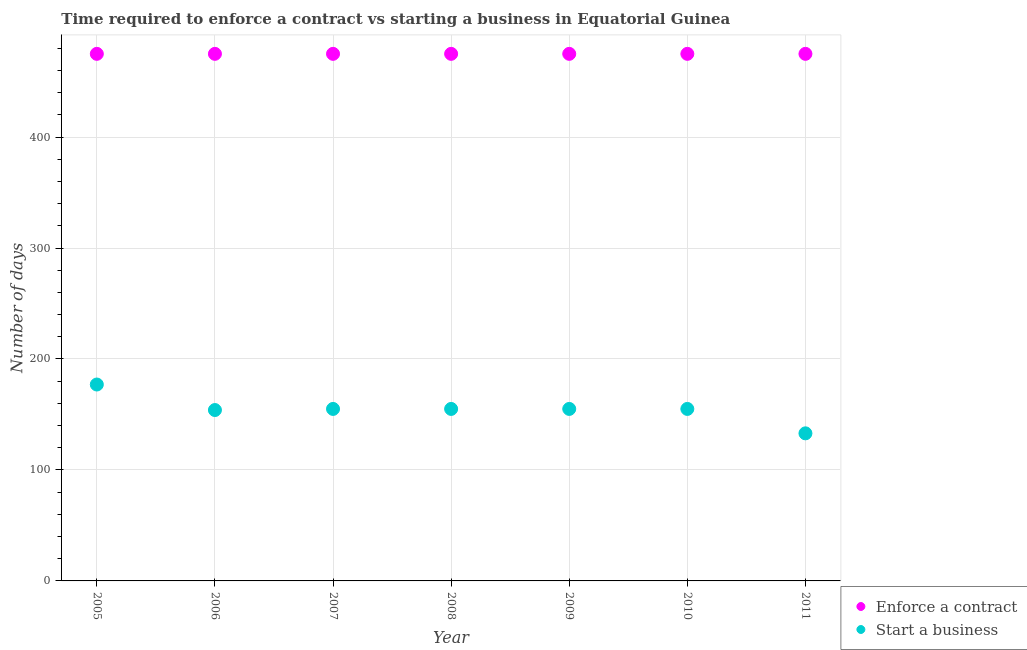What is the number of days to start a business in 2010?
Ensure brevity in your answer.  155. Across all years, what is the maximum number of days to start a business?
Keep it short and to the point. 177. Across all years, what is the minimum number of days to enforece a contract?
Make the answer very short. 475. In which year was the number of days to start a business maximum?
Ensure brevity in your answer.  2005. In which year was the number of days to enforece a contract minimum?
Provide a short and direct response. 2005. What is the total number of days to enforece a contract in the graph?
Provide a succinct answer. 3325. What is the difference between the number of days to start a business in 2005 and that in 2006?
Provide a succinct answer. 23. What is the difference between the number of days to start a business in 2008 and the number of days to enforece a contract in 2009?
Your answer should be compact. -320. What is the average number of days to enforece a contract per year?
Offer a very short reply. 475. In the year 2008, what is the difference between the number of days to start a business and number of days to enforece a contract?
Give a very brief answer. -320. In how many years, is the number of days to enforece a contract greater than 140 days?
Ensure brevity in your answer.  7. What is the ratio of the number of days to start a business in 2008 to that in 2011?
Keep it short and to the point. 1.17. Is the difference between the number of days to enforece a contract in 2007 and 2009 greater than the difference between the number of days to start a business in 2007 and 2009?
Provide a short and direct response. No. What is the difference between the highest and the second highest number of days to enforece a contract?
Your answer should be compact. 0. In how many years, is the number of days to start a business greater than the average number of days to start a business taken over all years?
Ensure brevity in your answer.  5. Is the sum of the number of days to enforece a contract in 2007 and 2008 greater than the maximum number of days to start a business across all years?
Provide a succinct answer. Yes. How many dotlines are there?
Ensure brevity in your answer.  2. How many years are there in the graph?
Keep it short and to the point. 7. What is the difference between two consecutive major ticks on the Y-axis?
Your answer should be very brief. 100. Are the values on the major ticks of Y-axis written in scientific E-notation?
Your answer should be compact. No. Does the graph contain any zero values?
Your response must be concise. No. Where does the legend appear in the graph?
Offer a very short reply. Bottom right. How many legend labels are there?
Offer a terse response. 2. What is the title of the graph?
Your answer should be compact. Time required to enforce a contract vs starting a business in Equatorial Guinea. What is the label or title of the Y-axis?
Your answer should be compact. Number of days. What is the Number of days of Enforce a contract in 2005?
Provide a succinct answer. 475. What is the Number of days in Start a business in 2005?
Your response must be concise. 177. What is the Number of days of Enforce a contract in 2006?
Your answer should be compact. 475. What is the Number of days in Start a business in 2006?
Make the answer very short. 154. What is the Number of days of Enforce a contract in 2007?
Give a very brief answer. 475. What is the Number of days in Start a business in 2007?
Your answer should be compact. 155. What is the Number of days in Enforce a contract in 2008?
Offer a terse response. 475. What is the Number of days in Start a business in 2008?
Make the answer very short. 155. What is the Number of days in Enforce a contract in 2009?
Offer a very short reply. 475. What is the Number of days in Start a business in 2009?
Make the answer very short. 155. What is the Number of days of Enforce a contract in 2010?
Your response must be concise. 475. What is the Number of days of Start a business in 2010?
Your answer should be compact. 155. What is the Number of days of Enforce a contract in 2011?
Provide a succinct answer. 475. What is the Number of days of Start a business in 2011?
Offer a terse response. 133. Across all years, what is the maximum Number of days in Enforce a contract?
Your answer should be very brief. 475. Across all years, what is the maximum Number of days of Start a business?
Keep it short and to the point. 177. Across all years, what is the minimum Number of days of Enforce a contract?
Give a very brief answer. 475. Across all years, what is the minimum Number of days in Start a business?
Offer a very short reply. 133. What is the total Number of days in Enforce a contract in the graph?
Offer a terse response. 3325. What is the total Number of days of Start a business in the graph?
Make the answer very short. 1084. What is the difference between the Number of days in Enforce a contract in 2005 and that in 2006?
Give a very brief answer. 0. What is the difference between the Number of days of Start a business in 2005 and that in 2006?
Your answer should be compact. 23. What is the difference between the Number of days of Start a business in 2005 and that in 2007?
Make the answer very short. 22. What is the difference between the Number of days of Start a business in 2005 and that in 2008?
Keep it short and to the point. 22. What is the difference between the Number of days of Enforce a contract in 2005 and that in 2009?
Offer a very short reply. 0. What is the difference between the Number of days of Start a business in 2005 and that in 2009?
Ensure brevity in your answer.  22. What is the difference between the Number of days of Enforce a contract in 2005 and that in 2011?
Provide a succinct answer. 0. What is the difference between the Number of days of Start a business in 2006 and that in 2007?
Your response must be concise. -1. What is the difference between the Number of days of Start a business in 2006 and that in 2008?
Your answer should be very brief. -1. What is the difference between the Number of days in Enforce a contract in 2006 and that in 2009?
Provide a succinct answer. 0. What is the difference between the Number of days in Start a business in 2006 and that in 2010?
Provide a short and direct response. -1. What is the difference between the Number of days of Enforce a contract in 2006 and that in 2011?
Your answer should be compact. 0. What is the difference between the Number of days in Start a business in 2006 and that in 2011?
Provide a succinct answer. 21. What is the difference between the Number of days of Enforce a contract in 2007 and that in 2009?
Ensure brevity in your answer.  0. What is the difference between the Number of days of Enforce a contract in 2007 and that in 2010?
Give a very brief answer. 0. What is the difference between the Number of days in Start a business in 2007 and that in 2010?
Keep it short and to the point. 0. What is the difference between the Number of days in Start a business in 2007 and that in 2011?
Offer a terse response. 22. What is the difference between the Number of days in Start a business in 2008 and that in 2010?
Offer a very short reply. 0. What is the difference between the Number of days of Enforce a contract in 2009 and that in 2010?
Your answer should be very brief. 0. What is the difference between the Number of days of Start a business in 2009 and that in 2010?
Give a very brief answer. 0. What is the difference between the Number of days in Enforce a contract in 2009 and that in 2011?
Your answer should be compact. 0. What is the difference between the Number of days of Start a business in 2009 and that in 2011?
Provide a short and direct response. 22. What is the difference between the Number of days in Enforce a contract in 2010 and that in 2011?
Your answer should be very brief. 0. What is the difference between the Number of days in Enforce a contract in 2005 and the Number of days in Start a business in 2006?
Your response must be concise. 321. What is the difference between the Number of days of Enforce a contract in 2005 and the Number of days of Start a business in 2007?
Offer a very short reply. 320. What is the difference between the Number of days of Enforce a contract in 2005 and the Number of days of Start a business in 2008?
Keep it short and to the point. 320. What is the difference between the Number of days of Enforce a contract in 2005 and the Number of days of Start a business in 2009?
Provide a short and direct response. 320. What is the difference between the Number of days in Enforce a contract in 2005 and the Number of days in Start a business in 2010?
Offer a terse response. 320. What is the difference between the Number of days in Enforce a contract in 2005 and the Number of days in Start a business in 2011?
Your response must be concise. 342. What is the difference between the Number of days in Enforce a contract in 2006 and the Number of days in Start a business in 2007?
Give a very brief answer. 320. What is the difference between the Number of days in Enforce a contract in 2006 and the Number of days in Start a business in 2008?
Make the answer very short. 320. What is the difference between the Number of days in Enforce a contract in 2006 and the Number of days in Start a business in 2009?
Give a very brief answer. 320. What is the difference between the Number of days of Enforce a contract in 2006 and the Number of days of Start a business in 2010?
Offer a very short reply. 320. What is the difference between the Number of days in Enforce a contract in 2006 and the Number of days in Start a business in 2011?
Your response must be concise. 342. What is the difference between the Number of days in Enforce a contract in 2007 and the Number of days in Start a business in 2008?
Ensure brevity in your answer.  320. What is the difference between the Number of days in Enforce a contract in 2007 and the Number of days in Start a business in 2009?
Provide a succinct answer. 320. What is the difference between the Number of days in Enforce a contract in 2007 and the Number of days in Start a business in 2010?
Offer a terse response. 320. What is the difference between the Number of days of Enforce a contract in 2007 and the Number of days of Start a business in 2011?
Offer a terse response. 342. What is the difference between the Number of days of Enforce a contract in 2008 and the Number of days of Start a business in 2009?
Provide a short and direct response. 320. What is the difference between the Number of days of Enforce a contract in 2008 and the Number of days of Start a business in 2010?
Make the answer very short. 320. What is the difference between the Number of days of Enforce a contract in 2008 and the Number of days of Start a business in 2011?
Provide a succinct answer. 342. What is the difference between the Number of days of Enforce a contract in 2009 and the Number of days of Start a business in 2010?
Offer a very short reply. 320. What is the difference between the Number of days in Enforce a contract in 2009 and the Number of days in Start a business in 2011?
Ensure brevity in your answer.  342. What is the difference between the Number of days in Enforce a contract in 2010 and the Number of days in Start a business in 2011?
Make the answer very short. 342. What is the average Number of days of Enforce a contract per year?
Ensure brevity in your answer.  475. What is the average Number of days of Start a business per year?
Ensure brevity in your answer.  154.86. In the year 2005, what is the difference between the Number of days in Enforce a contract and Number of days in Start a business?
Give a very brief answer. 298. In the year 2006, what is the difference between the Number of days in Enforce a contract and Number of days in Start a business?
Make the answer very short. 321. In the year 2007, what is the difference between the Number of days in Enforce a contract and Number of days in Start a business?
Give a very brief answer. 320. In the year 2008, what is the difference between the Number of days of Enforce a contract and Number of days of Start a business?
Give a very brief answer. 320. In the year 2009, what is the difference between the Number of days in Enforce a contract and Number of days in Start a business?
Make the answer very short. 320. In the year 2010, what is the difference between the Number of days in Enforce a contract and Number of days in Start a business?
Offer a terse response. 320. In the year 2011, what is the difference between the Number of days in Enforce a contract and Number of days in Start a business?
Provide a succinct answer. 342. What is the ratio of the Number of days in Enforce a contract in 2005 to that in 2006?
Your response must be concise. 1. What is the ratio of the Number of days in Start a business in 2005 to that in 2006?
Provide a succinct answer. 1.15. What is the ratio of the Number of days in Enforce a contract in 2005 to that in 2007?
Your answer should be compact. 1. What is the ratio of the Number of days of Start a business in 2005 to that in 2007?
Keep it short and to the point. 1.14. What is the ratio of the Number of days in Start a business in 2005 to that in 2008?
Your response must be concise. 1.14. What is the ratio of the Number of days of Enforce a contract in 2005 to that in 2009?
Make the answer very short. 1. What is the ratio of the Number of days in Start a business in 2005 to that in 2009?
Offer a terse response. 1.14. What is the ratio of the Number of days in Enforce a contract in 2005 to that in 2010?
Your answer should be compact. 1. What is the ratio of the Number of days of Start a business in 2005 to that in 2010?
Give a very brief answer. 1.14. What is the ratio of the Number of days of Enforce a contract in 2005 to that in 2011?
Give a very brief answer. 1. What is the ratio of the Number of days in Start a business in 2005 to that in 2011?
Your response must be concise. 1.33. What is the ratio of the Number of days in Start a business in 2006 to that in 2007?
Give a very brief answer. 0.99. What is the ratio of the Number of days of Enforce a contract in 2006 to that in 2008?
Keep it short and to the point. 1. What is the ratio of the Number of days of Start a business in 2006 to that in 2009?
Ensure brevity in your answer.  0.99. What is the ratio of the Number of days in Enforce a contract in 2006 to that in 2010?
Provide a short and direct response. 1. What is the ratio of the Number of days in Start a business in 2006 to that in 2010?
Provide a short and direct response. 0.99. What is the ratio of the Number of days in Start a business in 2006 to that in 2011?
Offer a terse response. 1.16. What is the ratio of the Number of days in Enforce a contract in 2007 to that in 2008?
Your response must be concise. 1. What is the ratio of the Number of days in Enforce a contract in 2007 to that in 2009?
Provide a short and direct response. 1. What is the ratio of the Number of days in Enforce a contract in 2007 to that in 2010?
Make the answer very short. 1. What is the ratio of the Number of days in Start a business in 2007 to that in 2011?
Offer a terse response. 1.17. What is the ratio of the Number of days of Start a business in 2008 to that in 2010?
Offer a terse response. 1. What is the ratio of the Number of days in Enforce a contract in 2008 to that in 2011?
Give a very brief answer. 1. What is the ratio of the Number of days in Start a business in 2008 to that in 2011?
Offer a terse response. 1.17. What is the ratio of the Number of days of Enforce a contract in 2009 to that in 2010?
Your answer should be compact. 1. What is the ratio of the Number of days in Start a business in 2009 to that in 2010?
Give a very brief answer. 1. What is the ratio of the Number of days in Start a business in 2009 to that in 2011?
Provide a short and direct response. 1.17. What is the ratio of the Number of days of Start a business in 2010 to that in 2011?
Offer a very short reply. 1.17. What is the difference between the highest and the second highest Number of days of Enforce a contract?
Your answer should be very brief. 0. What is the difference between the highest and the lowest Number of days of Start a business?
Your answer should be very brief. 44. 